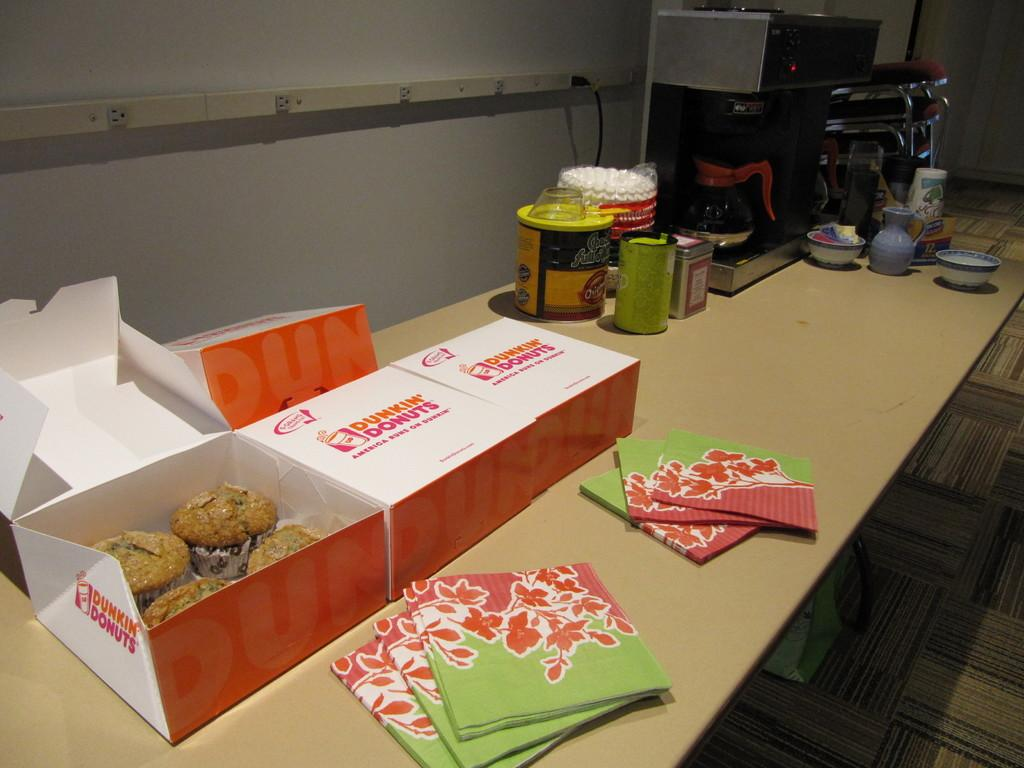<image>
Create a compact narrative representing the image presented. Dunkin' Donuts and refreshments are laid out on a table for patrons. 